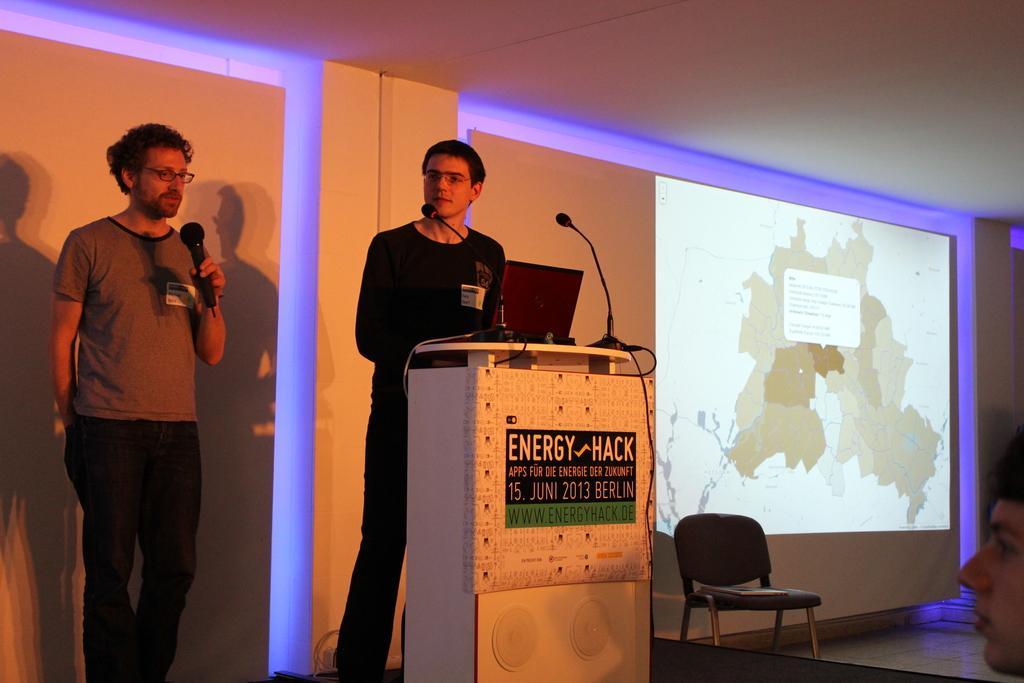In one or two sentences, can you explain what this image depicts? In the left a Man is standing and speaking in the microphone he wears a t-shirt and a pant and beside of him there is another man who is standing near the podium in the right there is a projected image map and its a chair at the middle. 